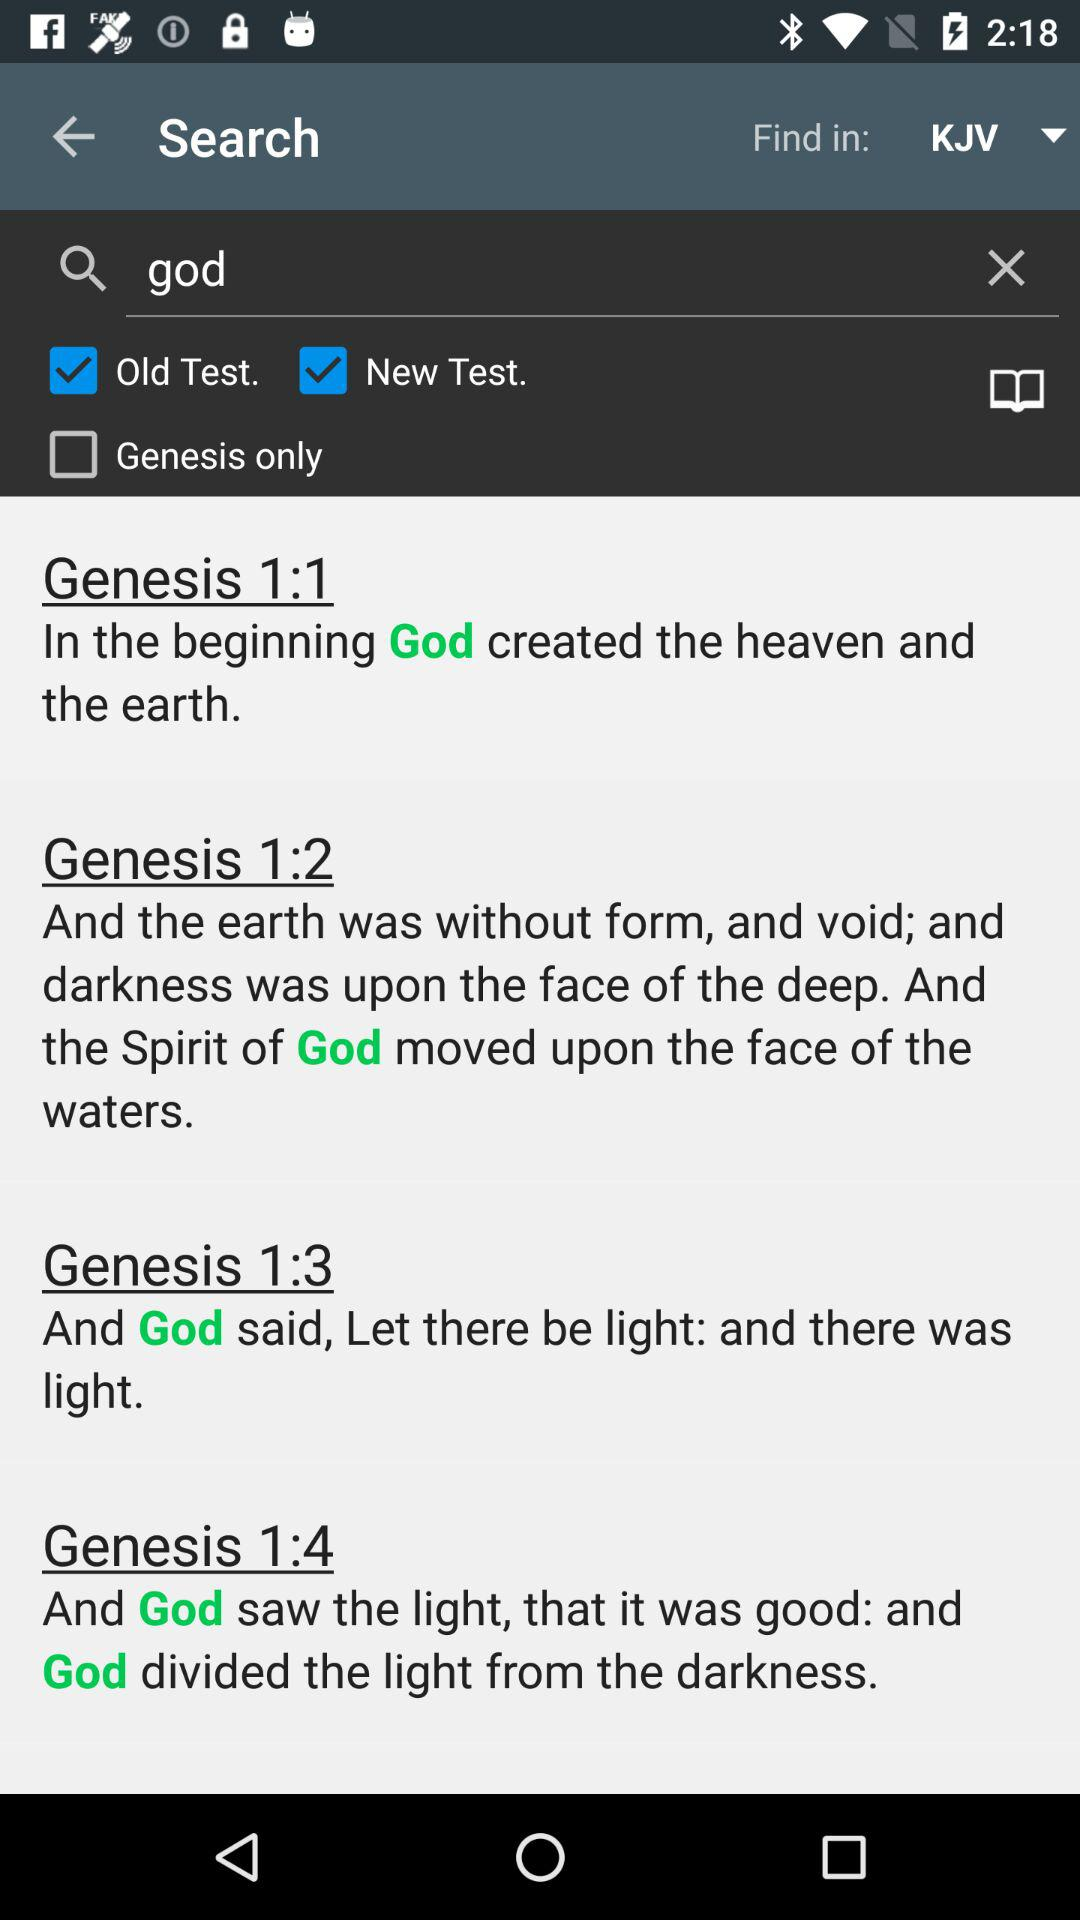What is the entered term in the search bar? The entered term is "god". 